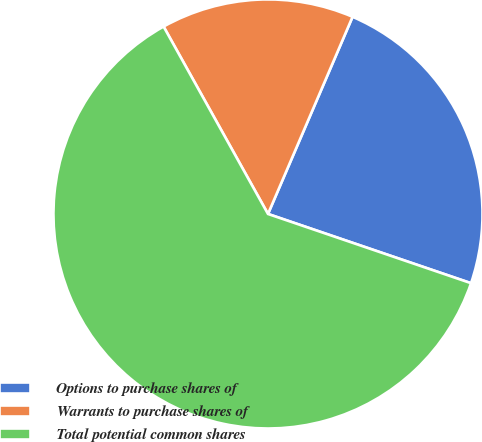Convert chart. <chart><loc_0><loc_0><loc_500><loc_500><pie_chart><fcel>Options to purchase shares of<fcel>Warrants to purchase shares of<fcel>Total potential common shares<nl><fcel>23.78%<fcel>14.54%<fcel>61.68%<nl></chart> 